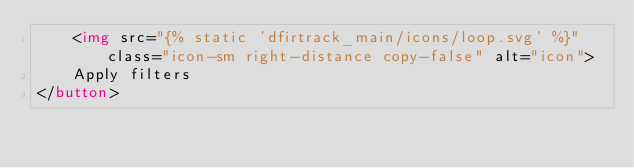Convert code to text. <code><loc_0><loc_0><loc_500><loc_500><_HTML_>    <img src="{% static 'dfirtrack_main/icons/loop.svg' %}" class="icon-sm right-distance copy-false" alt="icon">
    Apply filters
</button>
</code> 